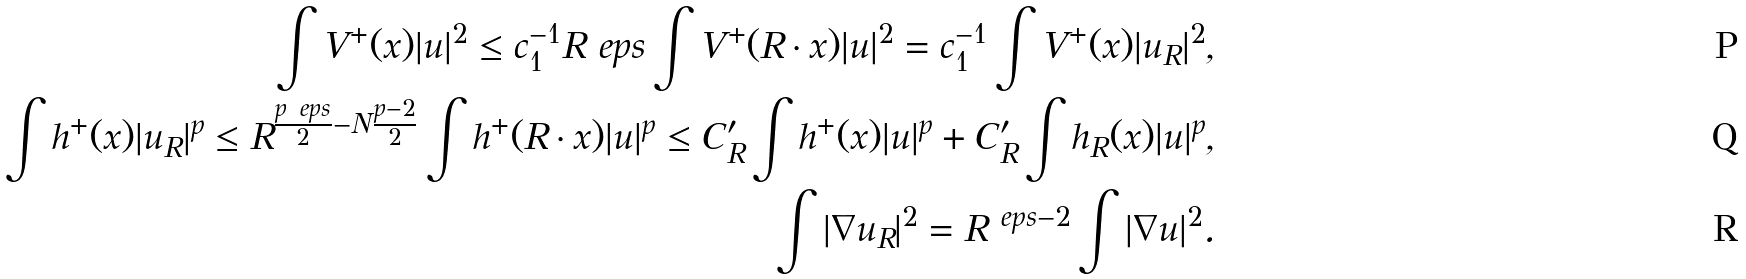Convert formula to latex. <formula><loc_0><loc_0><loc_500><loc_500>\int V ^ { + } ( x ) | u | ^ { 2 } \leq c _ { 1 } ^ { - 1 } R ^ { \ } e p s \int V ^ { + } ( R \cdot x ) | u | ^ { 2 } = c _ { 1 } ^ { - 1 } \int V ^ { + } ( x ) | u _ { R } | ^ { 2 } , \\ \int h ^ { + } ( x ) | u _ { R } | ^ { p } \leq R ^ { \frac { p \ e p s } { 2 } - N \frac { p - 2 } { 2 } } \int h ^ { + } ( R \cdot x ) | u | ^ { p } \leq C ^ { \prime } _ { R } \int h ^ { + } ( x ) | u | ^ { p } + C ^ { \prime } _ { R } \int h _ { R } ( x ) | u | ^ { p } , \\ \int | \nabla u _ { R } | ^ { 2 } = R ^ { \ e p s - 2 } \int | \nabla u | ^ { 2 } .</formula> 